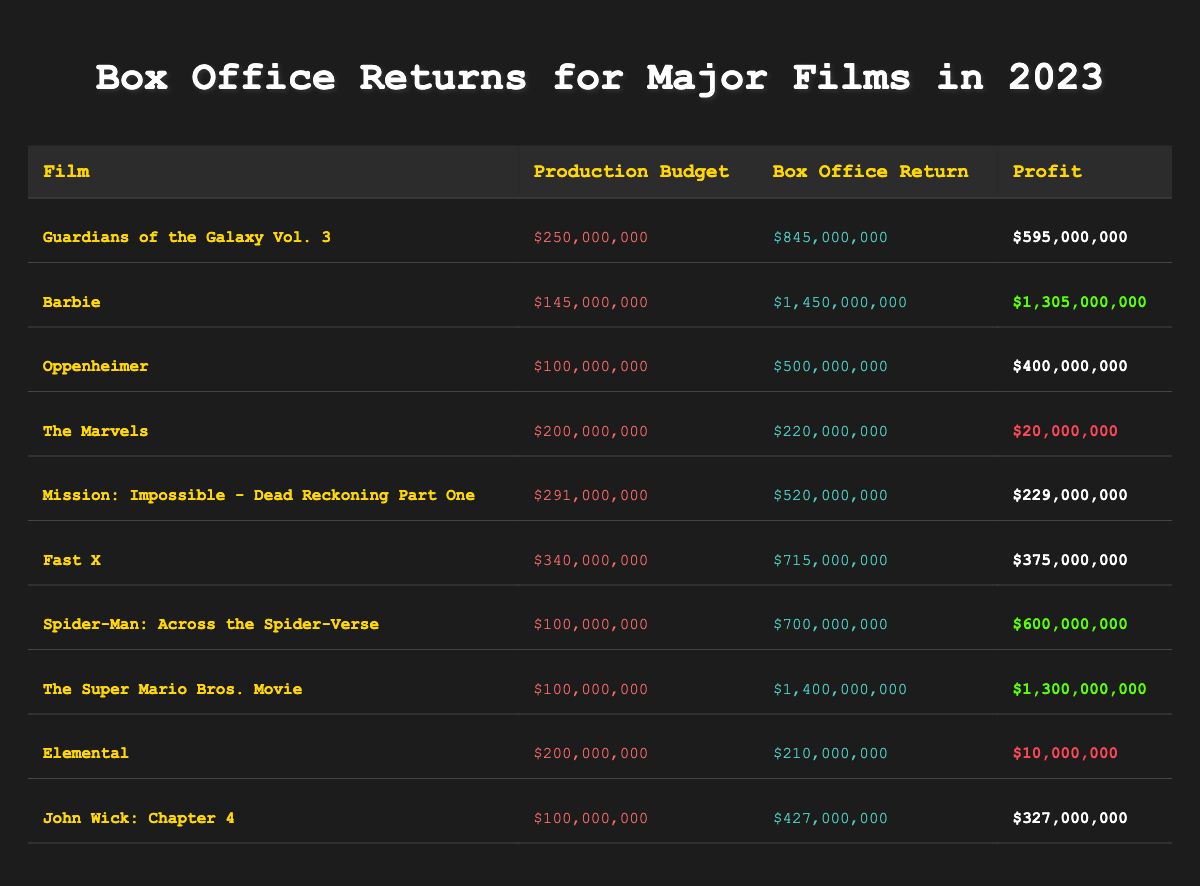What is the production budget for "Barbie"? Refer to the table row for "Barbie" to find the production budget listed under the Production Budget column, which is $145,000,000.
Answer: $145,000,000 Which film had the highest box office return in 2023? Looking at the Box Office Return column, "Barbie" has the highest value listed at $1,450,000,000.
Answer: $1,450,000,000 What was the profit for "The Marvels"? Check the row for "The Marvels" in the Profit column to see it listed as $20,000,000.
Answer: $20,000,000 Calculate the total profit for all films in the table. The profits for each film are summed up: $595,000,000 + $1,305,000,000 + $400,000,000 + $20,000,000 + $229,000,000 + $375,000,000 + $600,000,000 + $1,300,000,000 + $10,000,000 + $327,000,000 = $5,189,000,000.
Answer: $5,189,000,000 Did "Spider-Man: Across the Spider-Verse" make a profit of more than $600,000,000? Check the profit value for "Spider-Man: Across the Spider-Verse", which is $600,000,000, confirming that it did not exceed this amount.
Answer: No Which film had the lowest profit? By examining the Profit column, "Elemental" has the lowest profit listed at $10,000,000.
Answer: $10,000,000 What is the average production budget for all films listed? The total production budget is $250,000,000 + $145,000,000 + $100,000,000 + $200,000,000 + $291,000,000 + $340,000,000 + $100,000,000 + $100,000,000 + $200,000,000 + $100,000,000 = $1,825,000,000, and dividing by 10 gives an average of $182,500,000.
Answer: $182,500,000 If the production budget doubled for "Fast X", what would be its new profit at the current box office return? Doubling the production budget of $340,000,000 would be $680,000,000. The box office return is $715,000,000, so the new profit would be $715,000,000 - $680,000,000 = $35,000,000.
Answer: $35,000,000 What can we conclude about the relationship between production budgets and profits based on this table? Films with lower production budgets like "Barbie" and "The Super Mario Bros. Movie" showed very high profits, while some with higher budgets like "The Marvels" had minimal profit, suggesting that high budgets do not guarantee higher profits.
Answer: Higher budgets do not ensure higher profits 